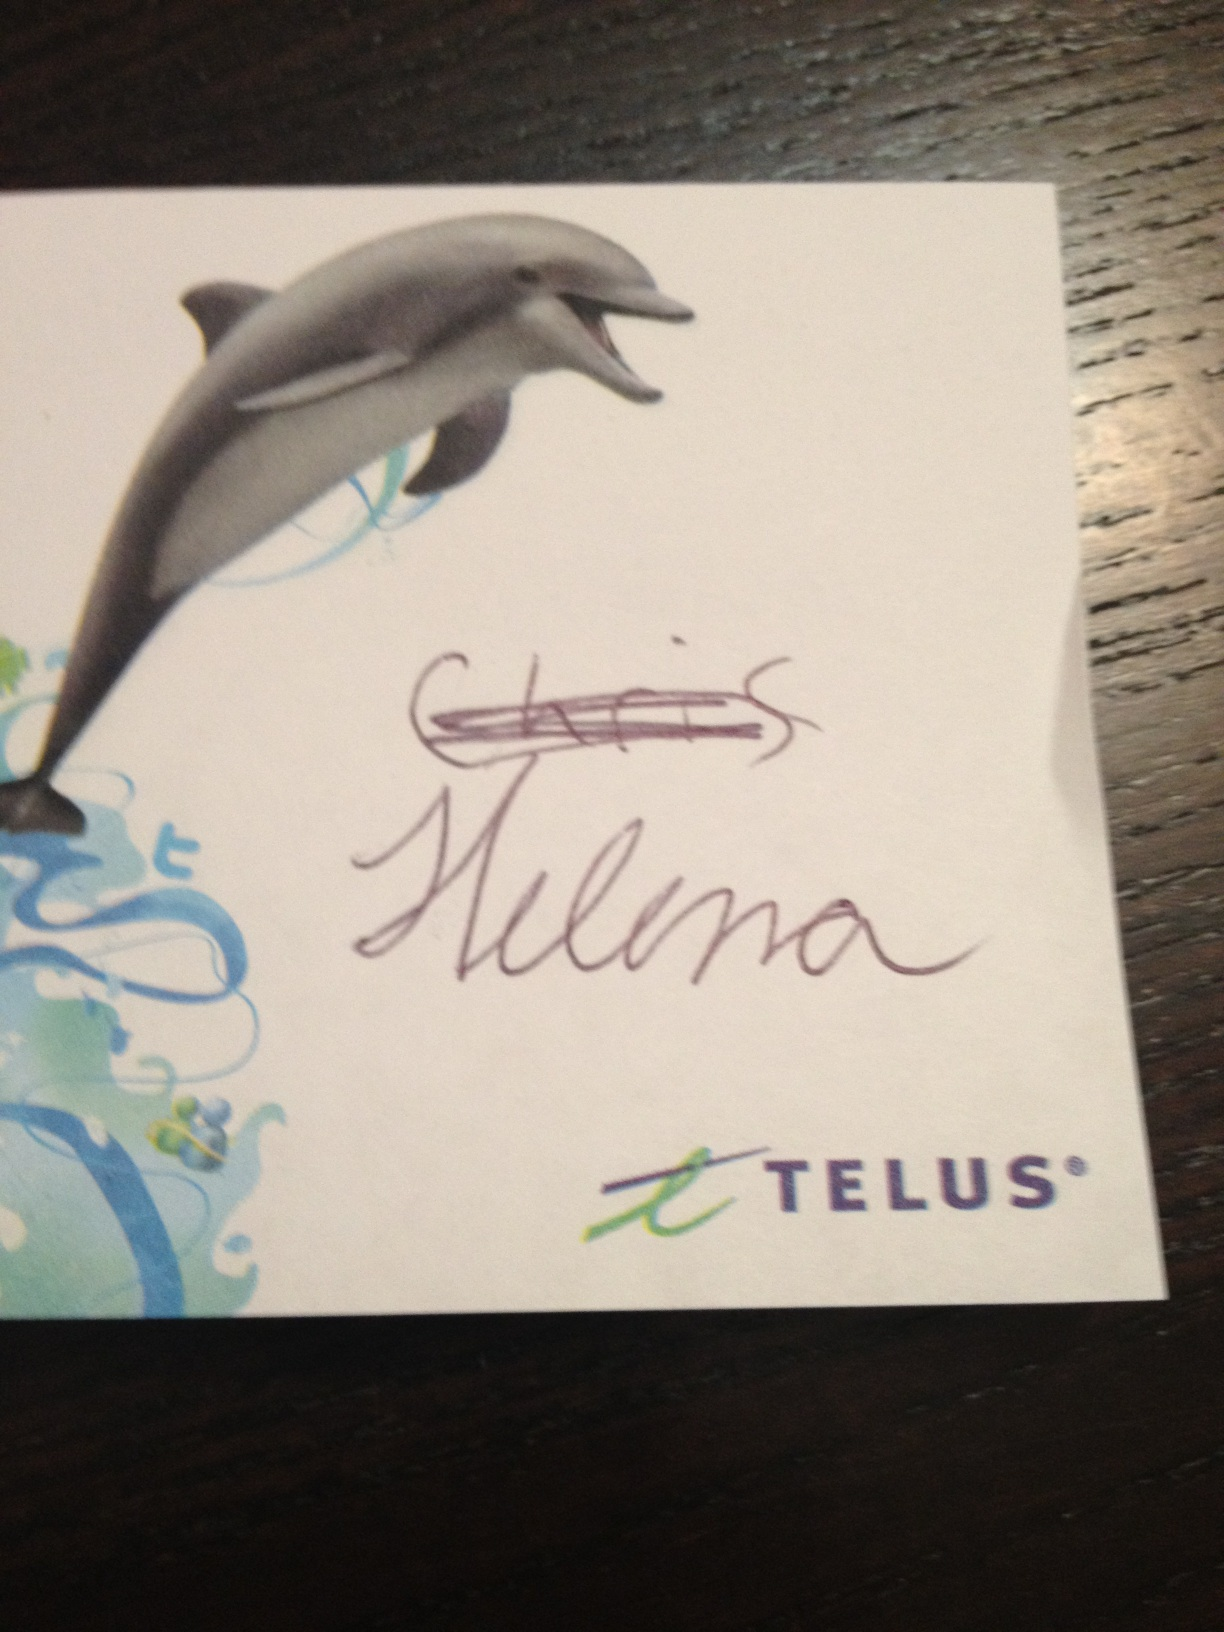What is the significance of the dolphin on this card? The dolphin likely symbolizes attributes associated with the brand, such as intelligence and friendliness. It also could be aimed to appeal to environmental consciousness, as dolphins are often seen as charismatic symbols of marine life conservation. 